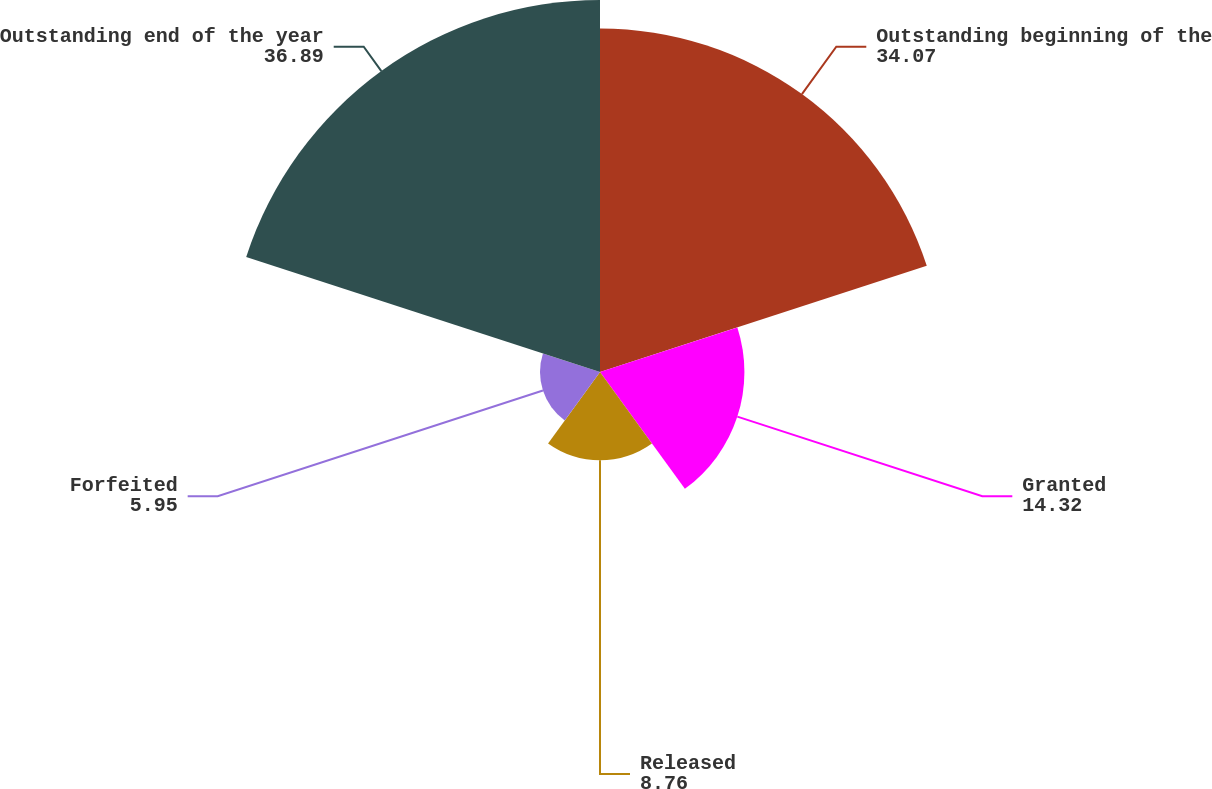Convert chart. <chart><loc_0><loc_0><loc_500><loc_500><pie_chart><fcel>Outstanding beginning of the<fcel>Granted<fcel>Released<fcel>Forfeited<fcel>Outstanding end of the year<nl><fcel>34.07%<fcel>14.32%<fcel>8.76%<fcel>5.95%<fcel>36.89%<nl></chart> 